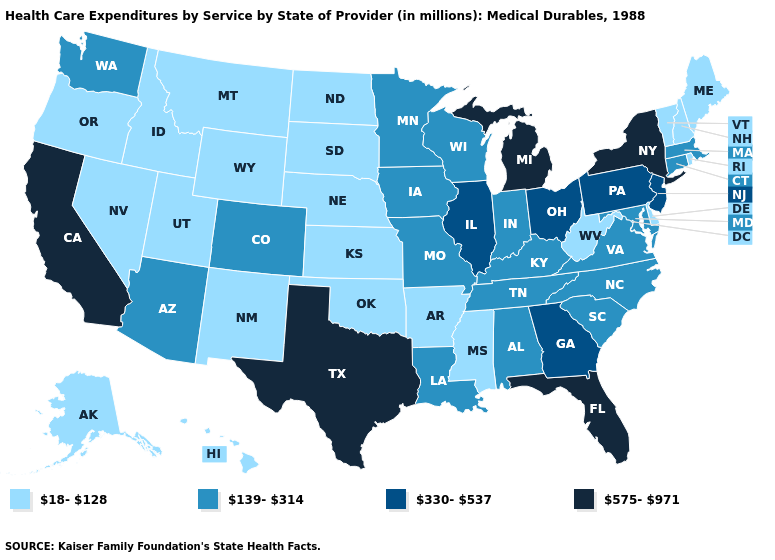Among the states that border New York , which have the lowest value?
Answer briefly. Vermont. What is the value of Nevada?
Give a very brief answer. 18-128. Among the states that border Delaware , does Maryland have the lowest value?
Give a very brief answer. Yes. Which states have the lowest value in the USA?
Concise answer only. Alaska, Arkansas, Delaware, Hawaii, Idaho, Kansas, Maine, Mississippi, Montana, Nebraska, Nevada, New Hampshire, New Mexico, North Dakota, Oklahoma, Oregon, Rhode Island, South Dakota, Utah, Vermont, West Virginia, Wyoming. Does Minnesota have a higher value than Connecticut?
Concise answer only. No. What is the value of Colorado?
Quick response, please. 139-314. How many symbols are there in the legend?
Short answer required. 4. Is the legend a continuous bar?
Short answer required. No. What is the lowest value in the USA?
Quick response, please. 18-128. Which states hav the highest value in the Northeast?
Concise answer only. New York. What is the value of Nebraska?
Give a very brief answer. 18-128. Does California have the highest value in the West?
Short answer required. Yes. What is the value of Utah?
Short answer required. 18-128. Name the states that have a value in the range 139-314?
Write a very short answer. Alabama, Arizona, Colorado, Connecticut, Indiana, Iowa, Kentucky, Louisiana, Maryland, Massachusetts, Minnesota, Missouri, North Carolina, South Carolina, Tennessee, Virginia, Washington, Wisconsin. Among the states that border Colorado , does Oklahoma have the lowest value?
Concise answer only. Yes. 